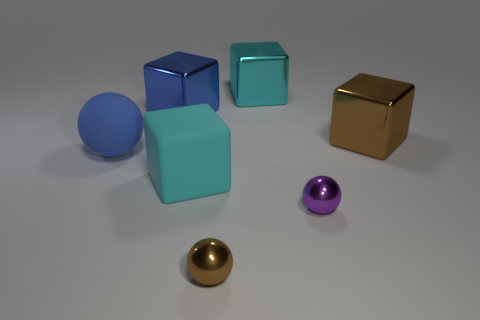How many objects are in the image in total, and can you describe their colors? There are six objects in total: two large cubes, one matte teal and the other shiny gold; two smaller cubes, one transparent teal and the other shiny purple; and two balls, one large blue rubber ball and a smaller shiny gold ball. Their colors add to the visual diversity of the scene. 